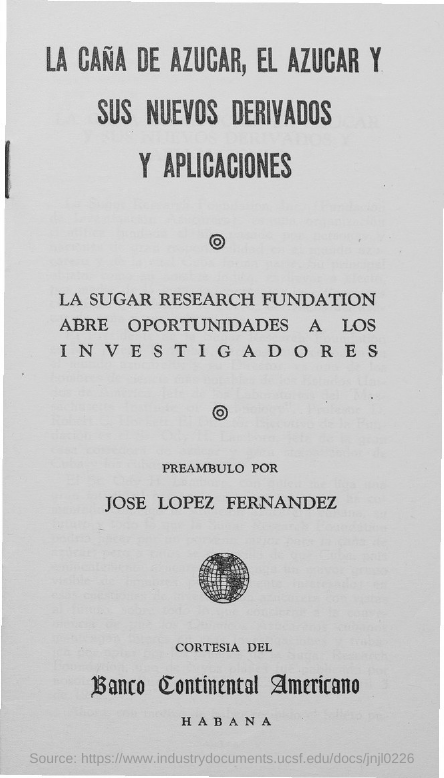Draw attention to some important aspects in this diagram. The person named in the document is Jose Lopez Fernandez. 